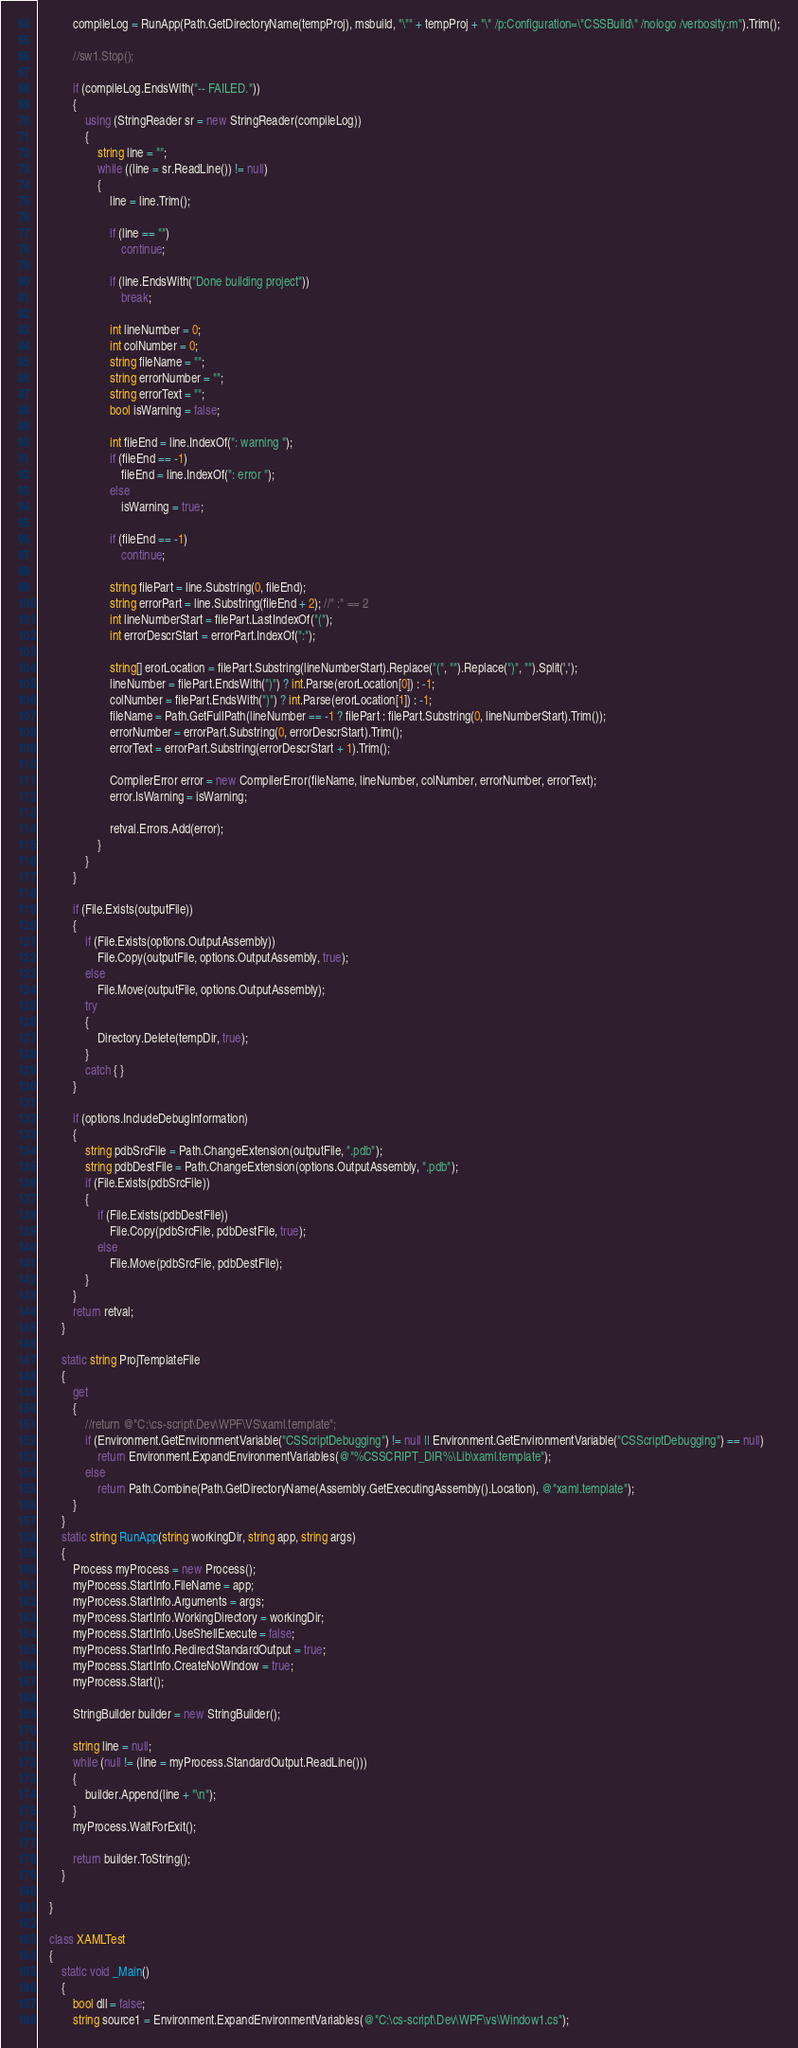<code> <loc_0><loc_0><loc_500><loc_500><_C#_>
            compileLog = RunApp(Path.GetDirectoryName(tempProj), msbuild, "\"" + tempProj + "\" /p:Configuration=\"CSSBuild\" /nologo /verbosity:m").Trim();

            //sw1.Stop();

            if (compileLog.EndsWith("-- FAILED."))
            {
                using (StringReader sr = new StringReader(compileLog))
                {
                    string line = "";
                    while ((line = sr.ReadLine()) != null)
                    {
                        line = line.Trim();

                        if (line == "")
                            continue;

                        if (line.EndsWith("Done building project"))
                            break;

                        int lineNumber = 0;
                        int colNumber = 0;
                        string fileName = "";
                        string errorNumber = "";
                        string errorText = "";
                        bool isWarning = false;

                        int fileEnd = line.IndexOf(": warning ");
                        if (fileEnd == -1)
                            fileEnd = line.IndexOf(": error ");
                        else
                            isWarning = true;

                        if (fileEnd == -1)
                            continue;

                        string filePart = line.Substring(0, fileEnd);
                        string errorPart = line.Substring(fileEnd + 2); //" :" == 2
                        int lineNumberStart = filePart.LastIndexOf("(");
                        int errorDescrStart = errorPart.IndexOf(":");

                        string[] erorLocation = filePart.Substring(lineNumberStart).Replace("(", "").Replace(")", "").Split(',');
                        lineNumber = filePart.EndsWith(")") ? int.Parse(erorLocation[0]) : -1;
                        colNumber = filePart.EndsWith(")") ? int.Parse(erorLocation[1]) : -1;
                        fileName = Path.GetFullPath(lineNumber == -1 ? filePart : filePart.Substring(0, lineNumberStart).Trim());
                        errorNumber = errorPart.Substring(0, errorDescrStart).Trim();
                        errorText = errorPart.Substring(errorDescrStart + 1).Trim();

                        CompilerError error = new CompilerError(fileName, lineNumber, colNumber, errorNumber, errorText);
                        error.IsWarning = isWarning;

                        retval.Errors.Add(error);
                    }
                }
            }

            if (File.Exists(outputFile))
            {
                if (File.Exists(options.OutputAssembly))
                    File.Copy(outputFile, options.OutputAssembly, true);
                else
                    File.Move(outputFile, options.OutputAssembly);
                try
                {
                    Directory.Delete(tempDir, true);
                }
                catch { }
            }

            if (options.IncludeDebugInformation)
            {
                string pdbSrcFile = Path.ChangeExtension(outputFile, ".pdb");
                string pdbDestFile = Path.ChangeExtension(options.OutputAssembly, ".pdb");
                if (File.Exists(pdbSrcFile))
                {
                    if (File.Exists(pdbDestFile))
                        File.Copy(pdbSrcFile, pdbDestFile, true);
                    else
                        File.Move(pdbSrcFile, pdbDestFile);
                }
            }
            return retval;
        }

        static string ProjTemplateFile
        {
            get
            {
                //return @"C:\cs-script\Dev\WPF\VS\xaml.template";
                if (Environment.GetEnvironmentVariable("CSScriptDebugging") != null || Environment.GetEnvironmentVariable("CSScriptDebugging") == null)
                    return Environment.ExpandEnvironmentVariables(@"%CSSCRIPT_DIR%\Lib\xaml.template");
                else
                    return Path.Combine(Path.GetDirectoryName(Assembly.GetExecutingAssembly().Location), @"xaml.template");
            }
        }
        static string RunApp(string workingDir, string app, string args)
        {
            Process myProcess = new Process();
            myProcess.StartInfo.FileName = app;
            myProcess.StartInfo.Arguments = args;
            myProcess.StartInfo.WorkingDirectory = workingDir;
            myProcess.StartInfo.UseShellExecute = false;
            myProcess.StartInfo.RedirectStandardOutput = true;
            myProcess.StartInfo.CreateNoWindow = true;
            myProcess.Start();

            StringBuilder builder = new StringBuilder();

            string line = null;
            while (null != (line = myProcess.StandardOutput.ReadLine()))
            {
                builder.Append(line + "\n");
            }
            myProcess.WaitForExit();

            return builder.ToString();
        }

    }

    class XAMLTest
    {
        static void _Main()
        {
            bool dll = false;
            string source1 = Environment.ExpandEnvironmentVariables(@"C:\cs-script\Dev\WPF\vs\Window1.cs");</code> 